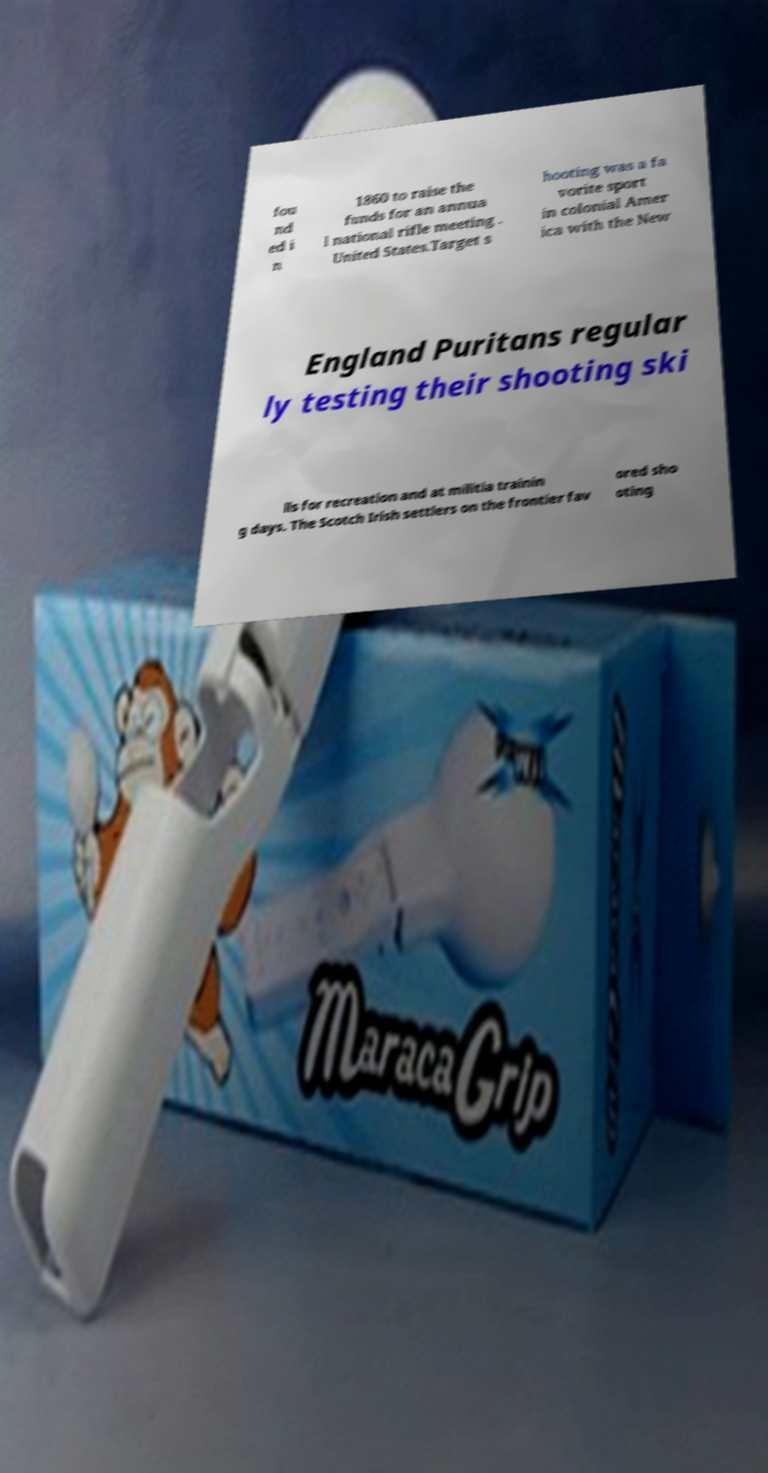Could you assist in decoding the text presented in this image and type it out clearly? fou nd ed i n 1860 to raise the funds for an annua l national rifle meeting . United States.Target s hooting was a fa vorite sport in colonial Amer ica with the New England Puritans regular ly testing their shooting ski lls for recreation and at militia trainin g days. The Scotch Irish settlers on the frontier fav ored sho oting 